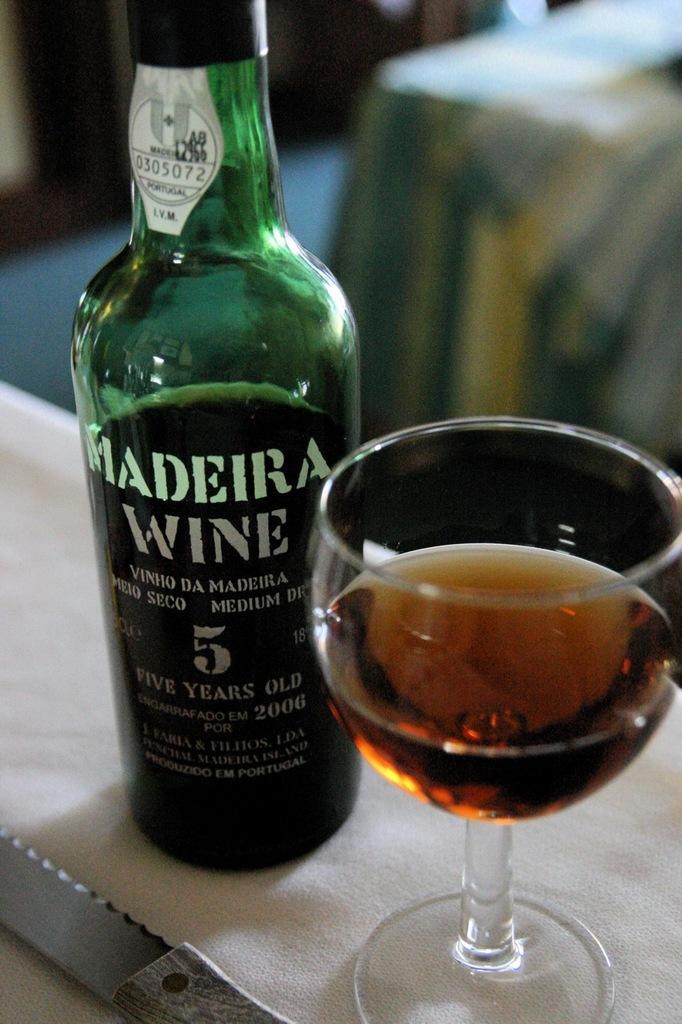Describe this image in one or two sentences. In this image I can see a green color bottle, knife and glass on the surface. Background is blurred. 